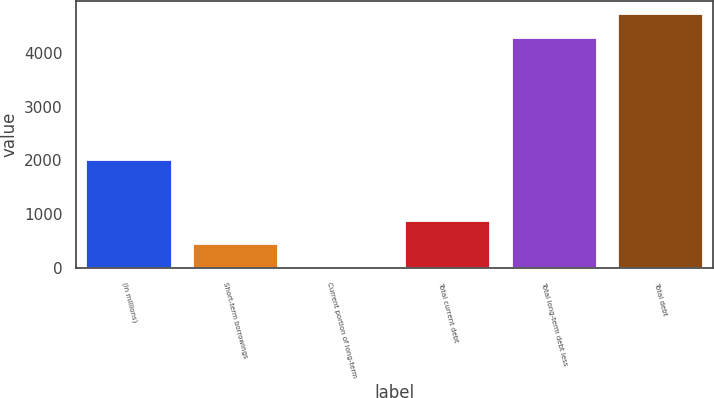Convert chart to OTSL. <chart><loc_0><loc_0><loc_500><loc_500><bar_chart><fcel>(In millions)<fcel>Short-term borrowings<fcel>Current portion of long-term<fcel>Total current debt<fcel>Total long-term debt less<fcel>Total debt<nl><fcel>2014<fcel>442.39<fcel>1.1<fcel>883.68<fcel>4282.5<fcel>4723.79<nl></chart> 